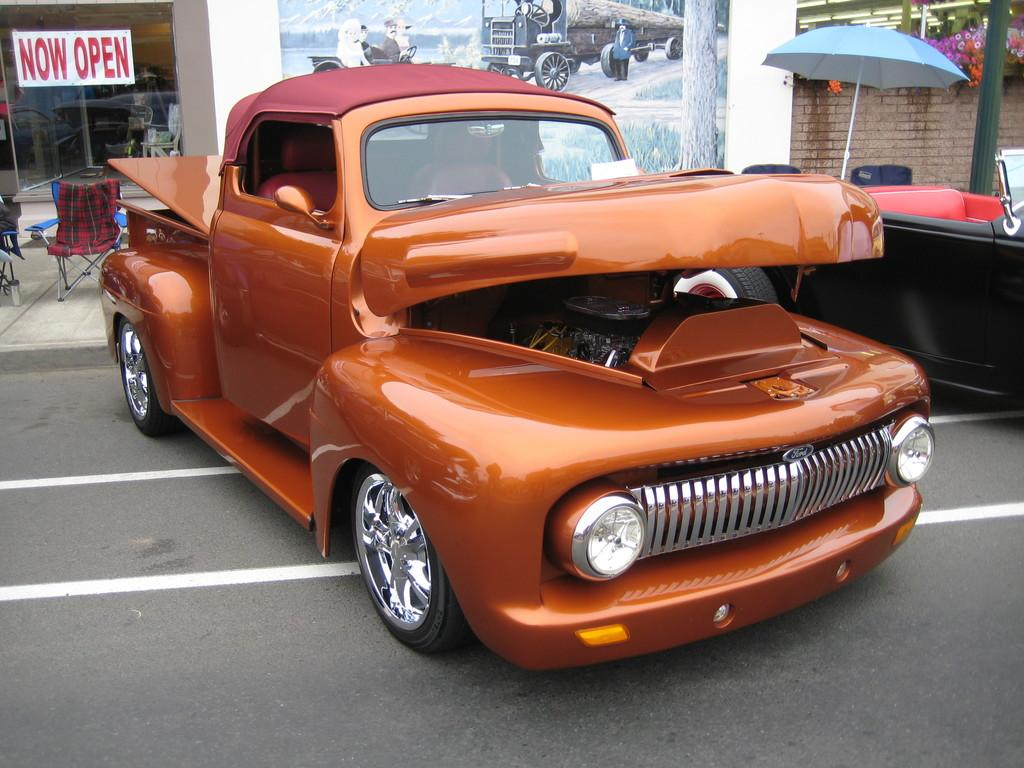How many cars are in the image? There are two cars in the image. What is located beside one of the cars? There is an umbrella beside one of the cars. What type of furniture is behind the orange car? There are two chairs behind the orange car. What can be seen in the distance in the image? There is a building visible in the background of the image. Can you see the geese flying in space in the image? There are no geese or space present in the image; it features two cars, an umbrella, chairs, and a building. 